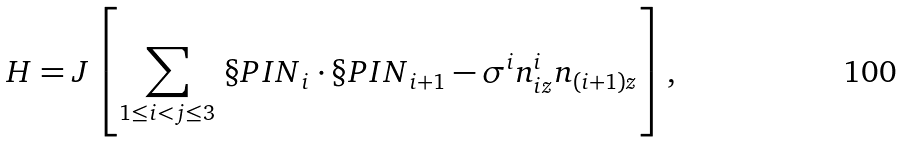Convert formula to latex. <formula><loc_0><loc_0><loc_500><loc_500>H = J \left [ \sum _ { 1 \leq i < j \leq 3 } \, { \S P I N } _ { i } \cdot { \S P I N } _ { i + 1 } - \sigma ^ { i } n _ { i z } ^ { i } n _ { ( i + 1 ) z } \right ] ,</formula> 